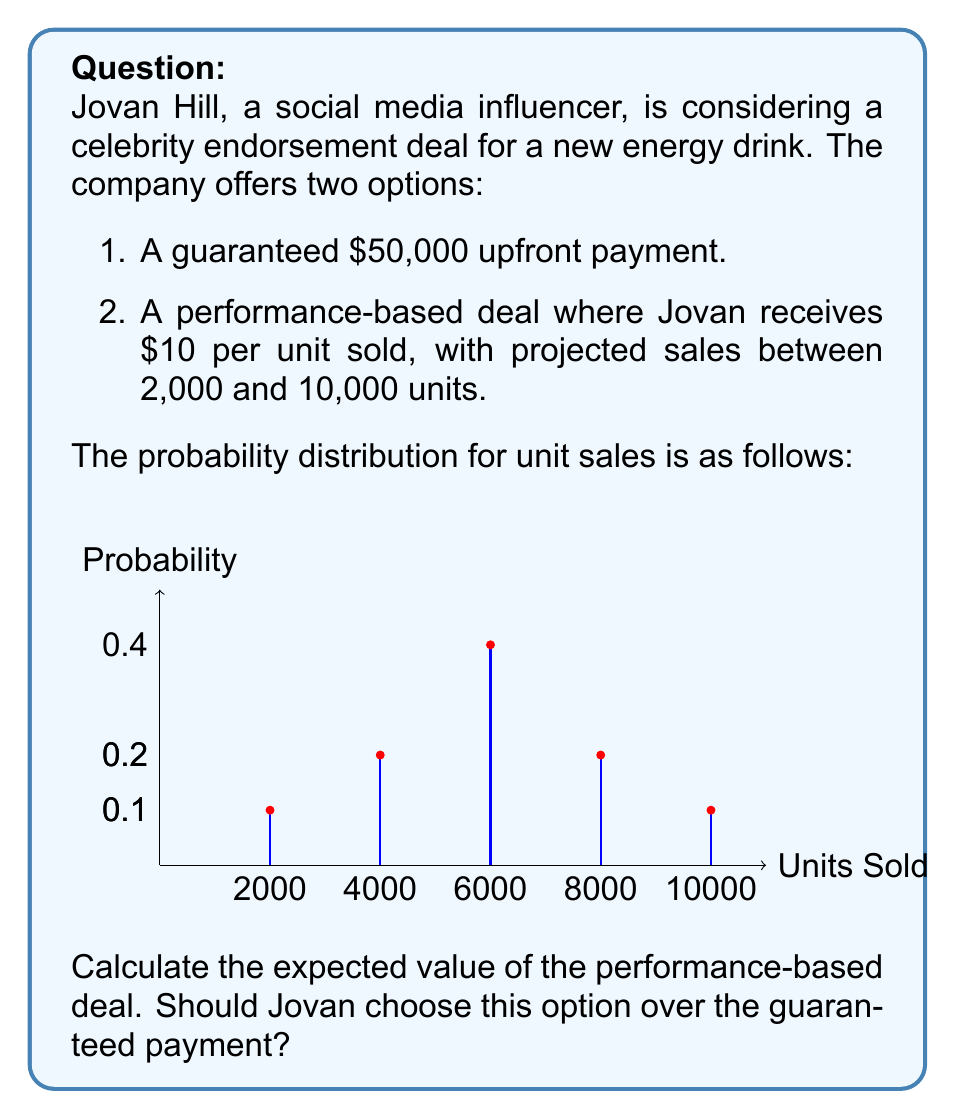Give your solution to this math problem. To solve this problem, we need to calculate the expected value of the performance-based deal and compare it to the guaranteed payment. Let's break it down step-by-step:

1. Calculate the payout for each possible outcome:
   - 2,000 units: $10 × 2,000 = $20,000
   - 4,000 units: $10 × 4,000 = $40,000
   - 6,000 units: $10 × 6,000 = $60,000
   - 8,000 units: $10 × 8,000 = $80,000
   - 10,000 units: $10 × 10,000 = $100,000

2. Calculate the expected value using the formula:
   $$E(X) = \sum_{i=1}^n x_i \cdot p(x_i)$$
   Where $x_i$ is the payout for each outcome and $p(x_i)$ is the probability of that outcome.

3. Plug in the values:
   $$E(X) = (20,000 \cdot 0.1) + (40,000 \cdot 0.2) + (60,000 \cdot 0.4) + (80,000 \cdot 0.2) + (100,000 \cdot 0.1)$$

4. Calculate:
   $$E(X) = 2,000 + 8,000 + 24,000 + 16,000 + 10,000 = 60,000$$

5. Compare the expected value to the guaranteed payment:
   The expected value of the performance-based deal ($60,000) is greater than the guaranteed payment ($50,000).

6. Consider risk tolerance:
   While the expected value is higher for the performance-based deal, it comes with uncertainty. Jovan should consider his risk tolerance and financial situation when making the decision.
Answer: $60,000; Yes, if risk-tolerant. 